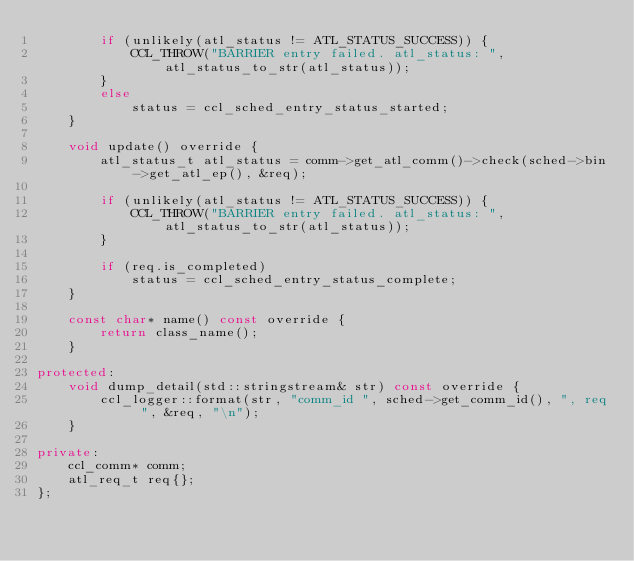Convert code to text. <code><loc_0><loc_0><loc_500><loc_500><_C++_>        if (unlikely(atl_status != ATL_STATUS_SUCCESS)) {
            CCL_THROW("BARRIER entry failed. atl_status: ", atl_status_to_str(atl_status));
        }
        else
            status = ccl_sched_entry_status_started;
    }

    void update() override {
        atl_status_t atl_status = comm->get_atl_comm()->check(sched->bin->get_atl_ep(), &req);

        if (unlikely(atl_status != ATL_STATUS_SUCCESS)) {
            CCL_THROW("BARRIER entry failed. atl_status: ", atl_status_to_str(atl_status));
        }

        if (req.is_completed)
            status = ccl_sched_entry_status_complete;
    }

    const char* name() const override {
        return class_name();
    }

protected:
    void dump_detail(std::stringstream& str) const override {
        ccl_logger::format(str, "comm_id ", sched->get_comm_id(), ", req ", &req, "\n");
    }

private:
    ccl_comm* comm;
    atl_req_t req{};
};
</code> 